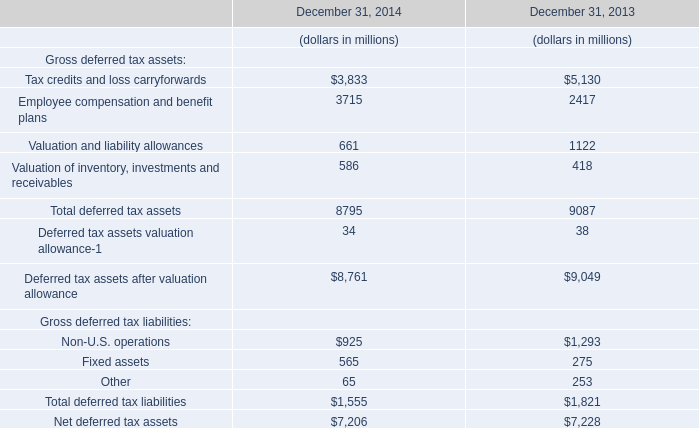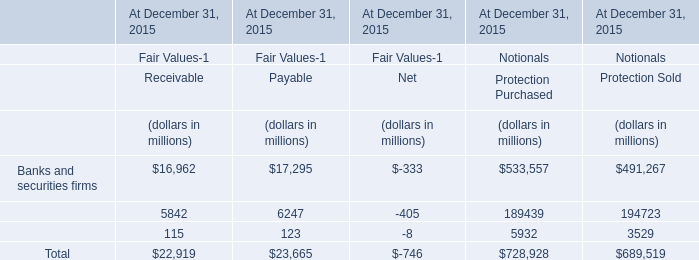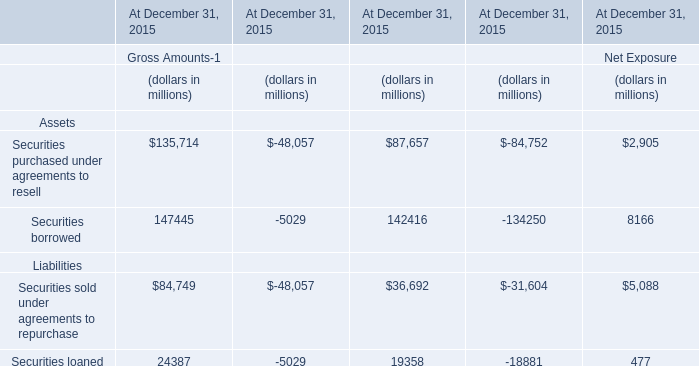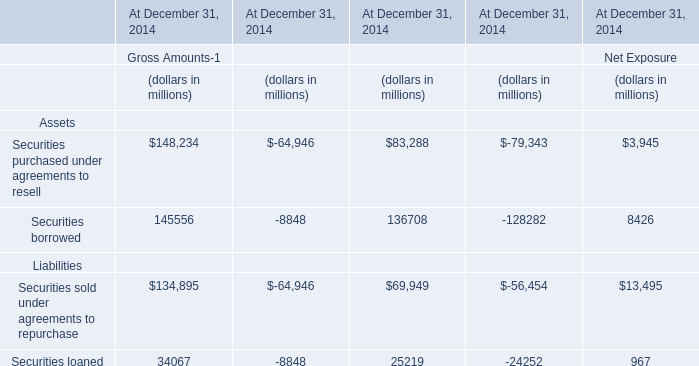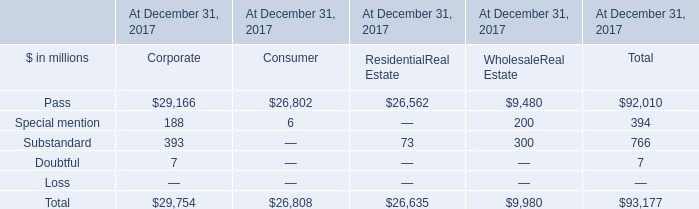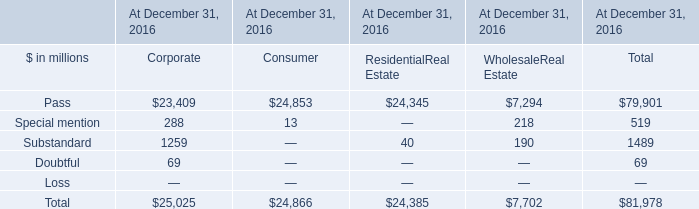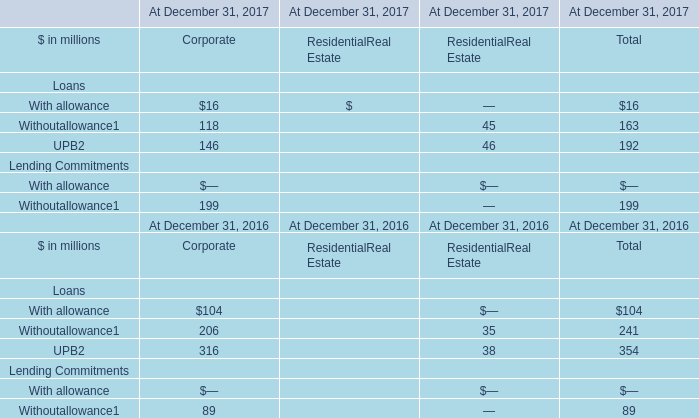What is the ratio of all Substandard that are smaller than 200 to the sum of Substandard, in 2016? 
Computations: ((40 + 190) / 1489)
Answer: 0.15447. 